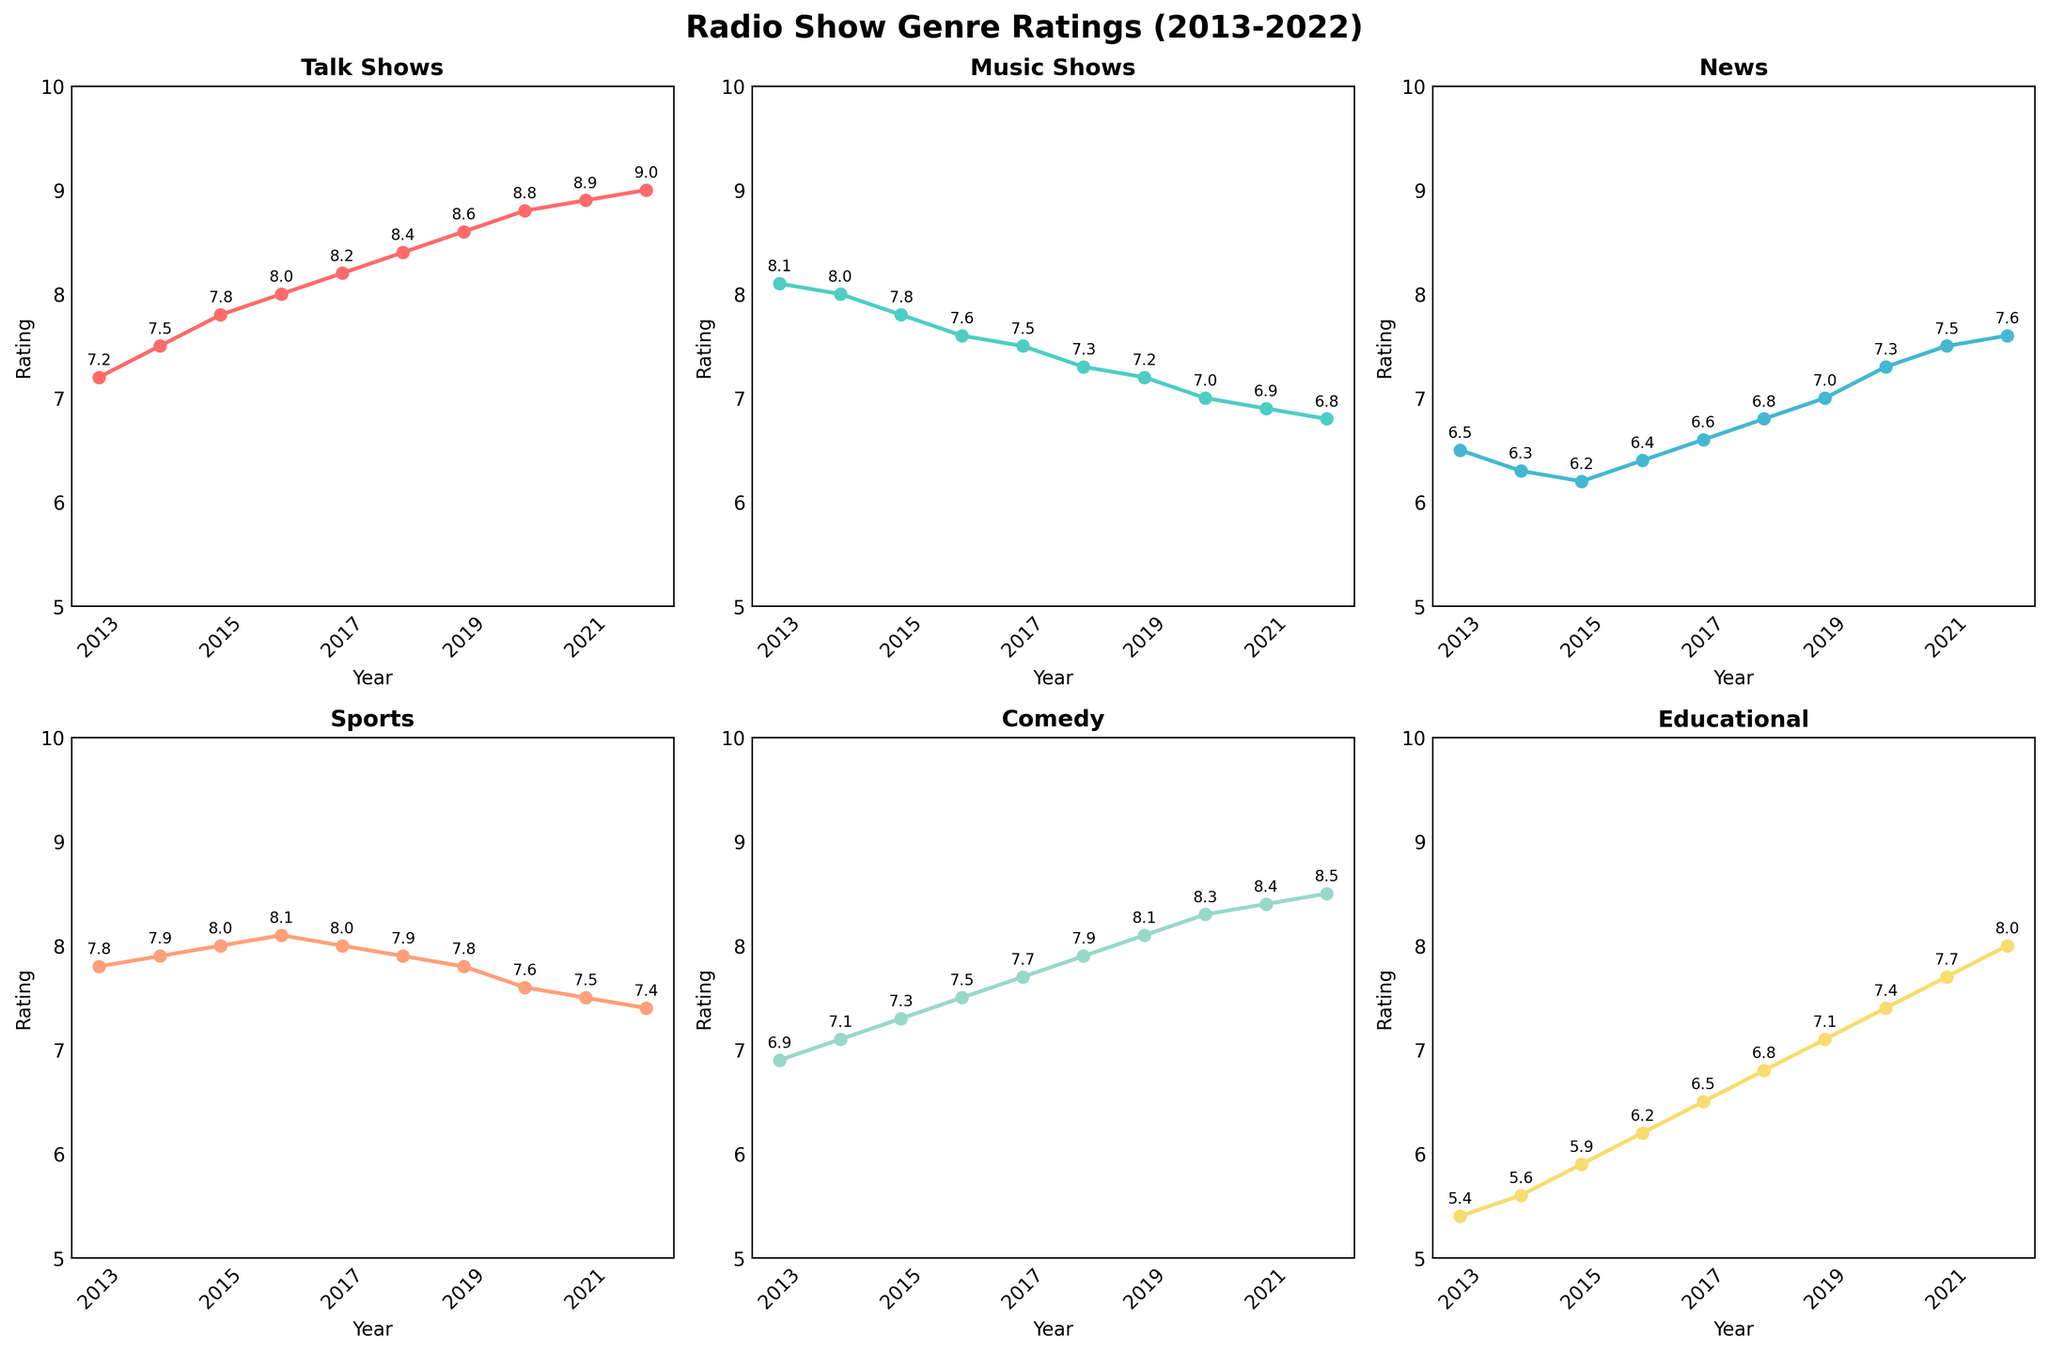What's the title of the figure? The title is displayed at the top center of the figure and reads "Radio Show Genre Ratings (2013-2022)".
Answer: Radio Show Genre Ratings (2013-2022) How many genres are plotted in the figure? There are six different genres; each subplot has a title corresponding to a genre: Talk Shows, Music Shows, News, Sports, Comedy, and Educational.
Answer: Six Which genre had the highest rating in 2022? The highest rating in 2022 is 9.0 in the Talk Shows subplot, as indicated by the annotated data points.
Answer: Talk Shows What is the overall trend for Music Shows from 2013 to 2022? The ratings for Music Shows generally decrease over time, starting from 8.1 in 2013 and dropping to 6.8 by 2022.
Answer: Decreasing How did the ratings for Comedy Shows change from 2019 to 2020? The Comedy Shows ratings increased from 8.1 in 2019 to 8.3 in 2020, as seen in the annotated ratings on the subplot for Comedy.
Answer: Increased What genre showed an increasing trend in its ratings throughout the entire decade? The Talk Shows genre shows an increasing trend from 7.2 in 2013 to 9.0 in 2022, as seen from both the line plot and the annotated ratings on the Talk Shows subplot.
Answer: Talk Shows In which years did the News genre have the same rating? The News genre had the same rating of 6.2 in 2015 and 2016 as seen from the annotated data points in the News subplot.
Answer: 2015 and 2016 Compare the rating changes in Sports Shows from 2013 to 2022 to those in Educational Shows. The rating for Sports Shows slightly decreased from 7.8 in 2013 to 7.4 in 2022, while Educational Shows increased from 5.4 in 2013 to 8.0 in 2022.
Answer: Sports decreased, Educational increased Which two genres had the closest ratings in 2021 and what were they? In 2021, the Comedy and Educational genres had close ratings of 8.4 and 7.7, respectively, as indicated by their annotated values in their respective subplots.
Answer: Comedy (8.4) and Educational (7.7) Find the average rating of Talk Shows between 2013 and 2022. The sum of Talk Shows ratings from 2013 to 2022 is 7.2 + 7.5 + 7.8 + 8.0 + 8.2 + 8.4 + 8.6 + 8.8 + 8.9 + 9.0 = 82.4. The average is 82.4 divided by 10 = 8.24.
Answer: 8.24 